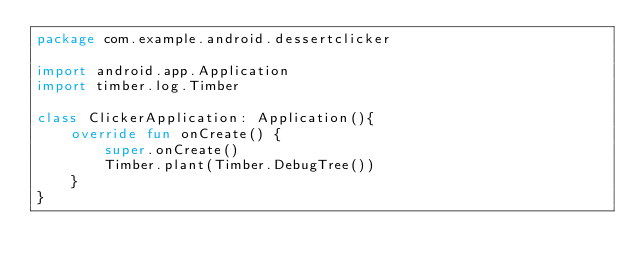Convert code to text. <code><loc_0><loc_0><loc_500><loc_500><_Kotlin_>package com.example.android.dessertclicker

import android.app.Application
import timber.log.Timber

class ClickerApplication: Application(){
    override fun onCreate() {
        super.onCreate()
        Timber.plant(Timber.DebugTree())
    }
}</code> 